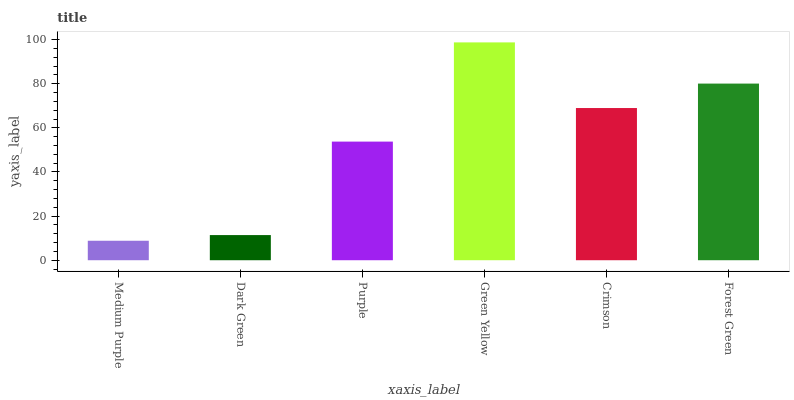Is Medium Purple the minimum?
Answer yes or no. Yes. Is Green Yellow the maximum?
Answer yes or no. Yes. Is Dark Green the minimum?
Answer yes or no. No. Is Dark Green the maximum?
Answer yes or no. No. Is Dark Green greater than Medium Purple?
Answer yes or no. Yes. Is Medium Purple less than Dark Green?
Answer yes or no. Yes. Is Medium Purple greater than Dark Green?
Answer yes or no. No. Is Dark Green less than Medium Purple?
Answer yes or no. No. Is Crimson the high median?
Answer yes or no. Yes. Is Purple the low median?
Answer yes or no. Yes. Is Purple the high median?
Answer yes or no. No. Is Crimson the low median?
Answer yes or no. No. 